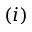Convert formula to latex. <formula><loc_0><loc_0><loc_500><loc_500>( i )</formula> 